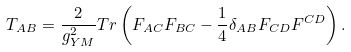<formula> <loc_0><loc_0><loc_500><loc_500>T _ { A B } = \frac { 2 } { g ^ { 2 } _ { Y M } } T r \left ( F _ { A C } F _ { B C } - \frac { 1 } { 4 } \delta _ { A B } F _ { C D } F ^ { C D } \right ) .</formula> 